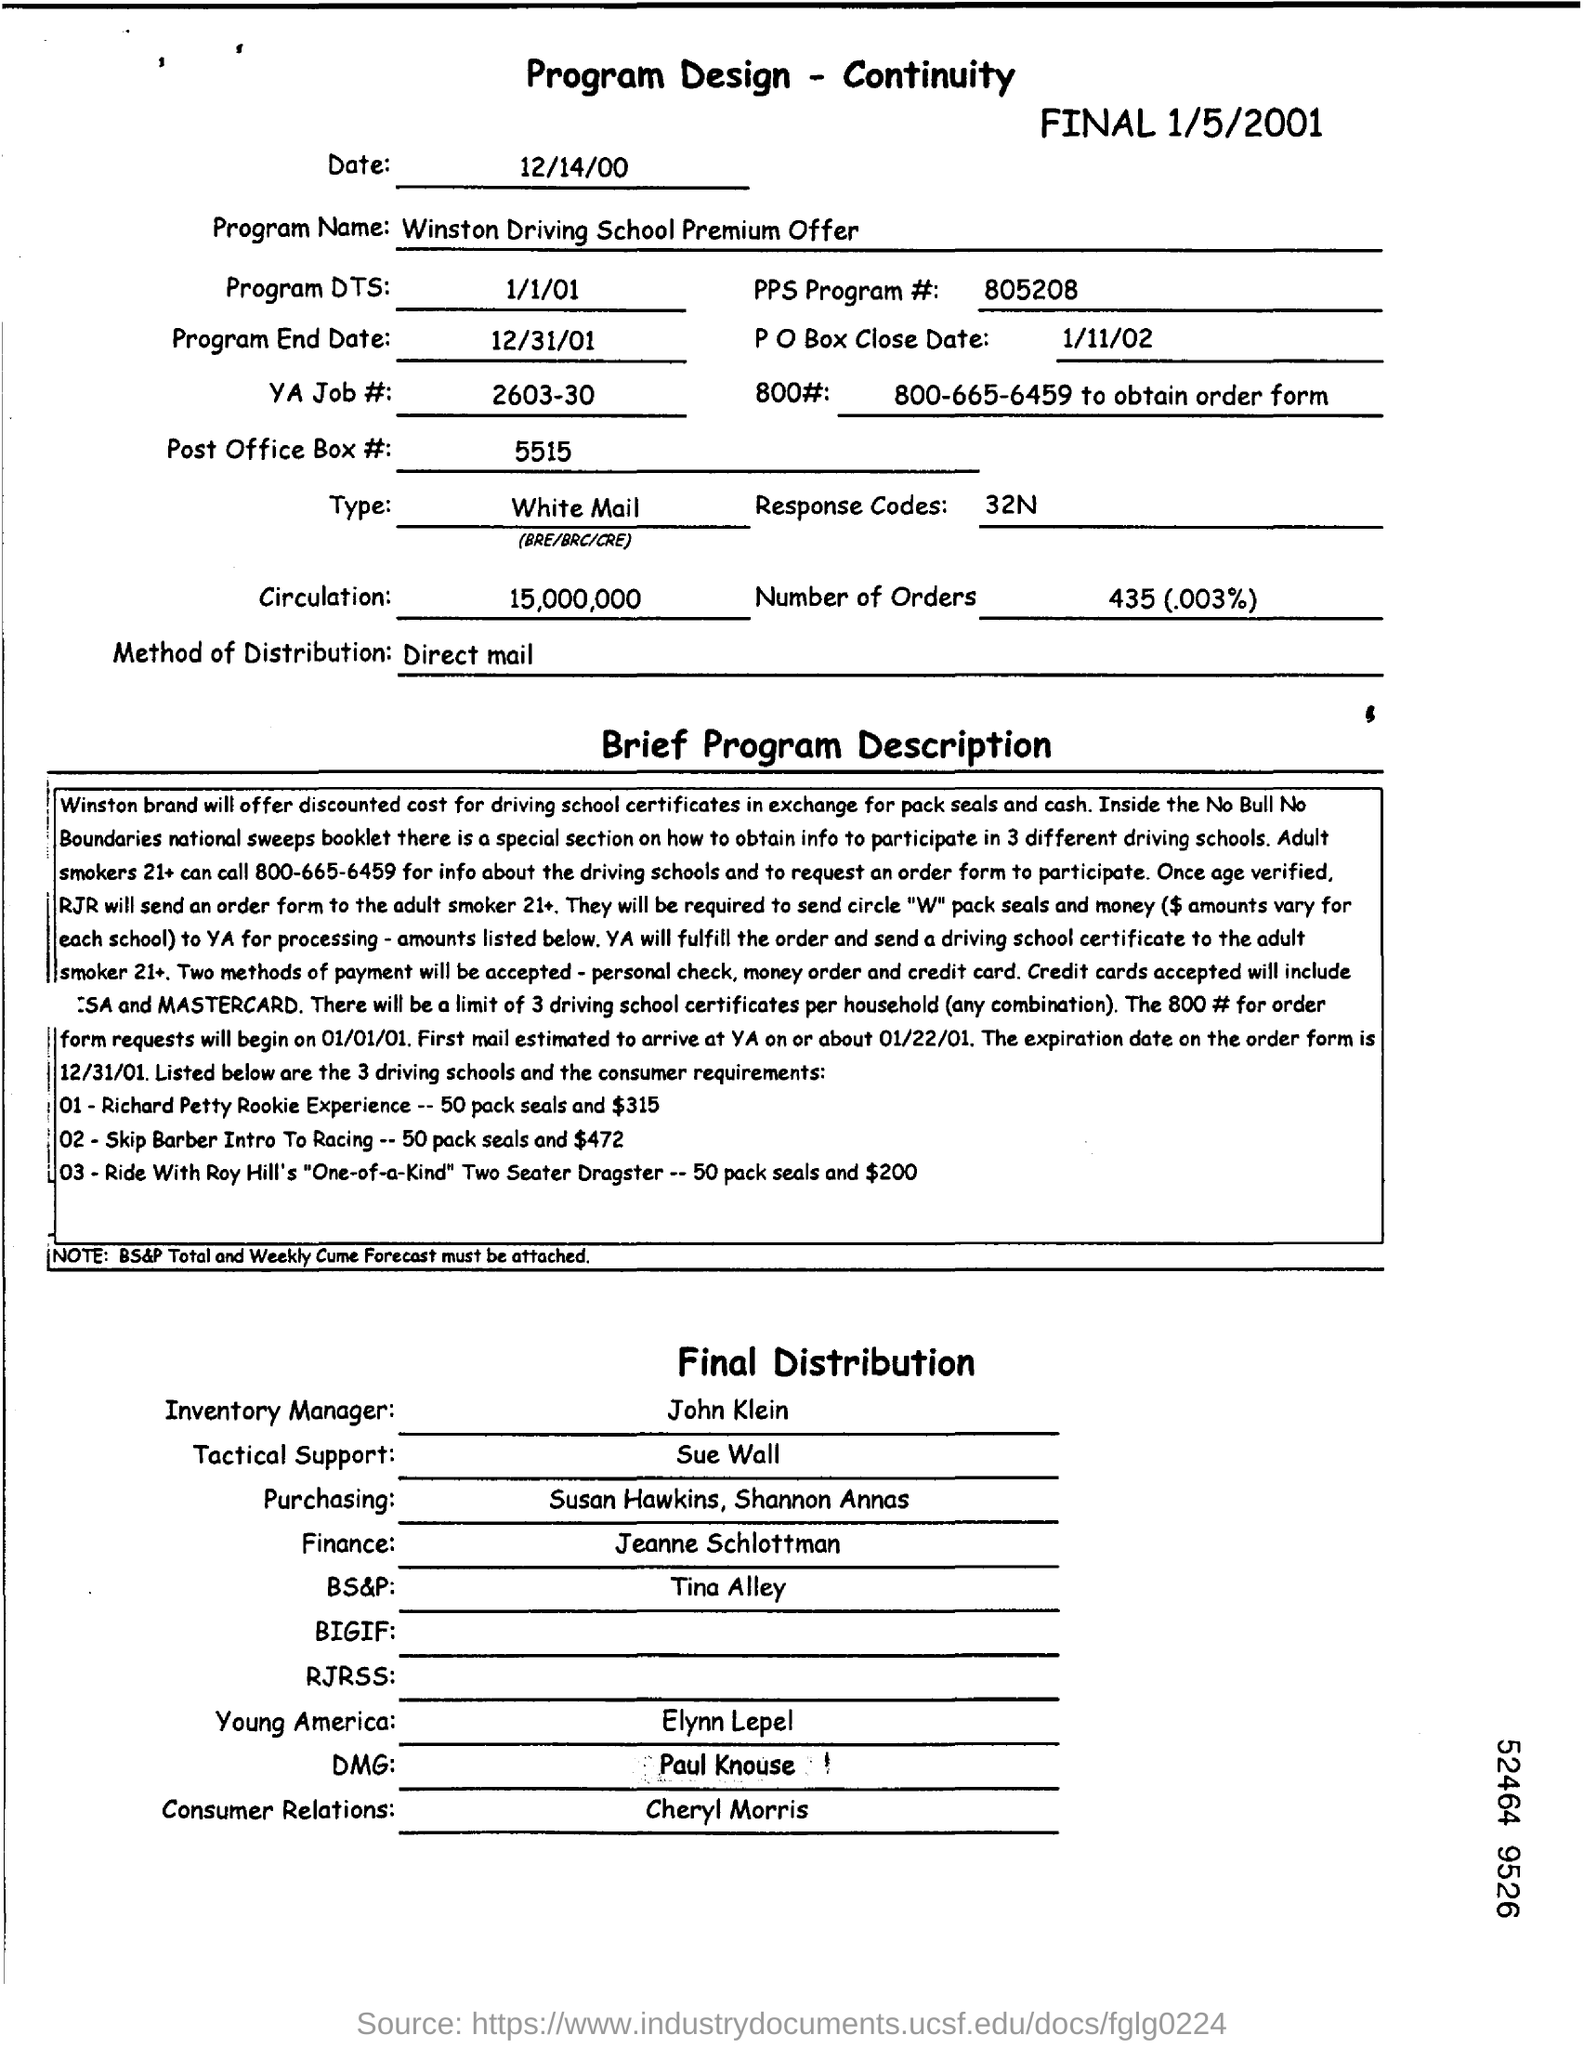Give some essential details in this illustration. The YA JOB number is 2603-30. The PPS Program # is 805208. John Klein is the inventory manager. The program end date is December 31, 2001. The heading of the document is "Program Design - Continuity," which indicates its focus on developing a program that prioritizes continuity in its design and implementation. 